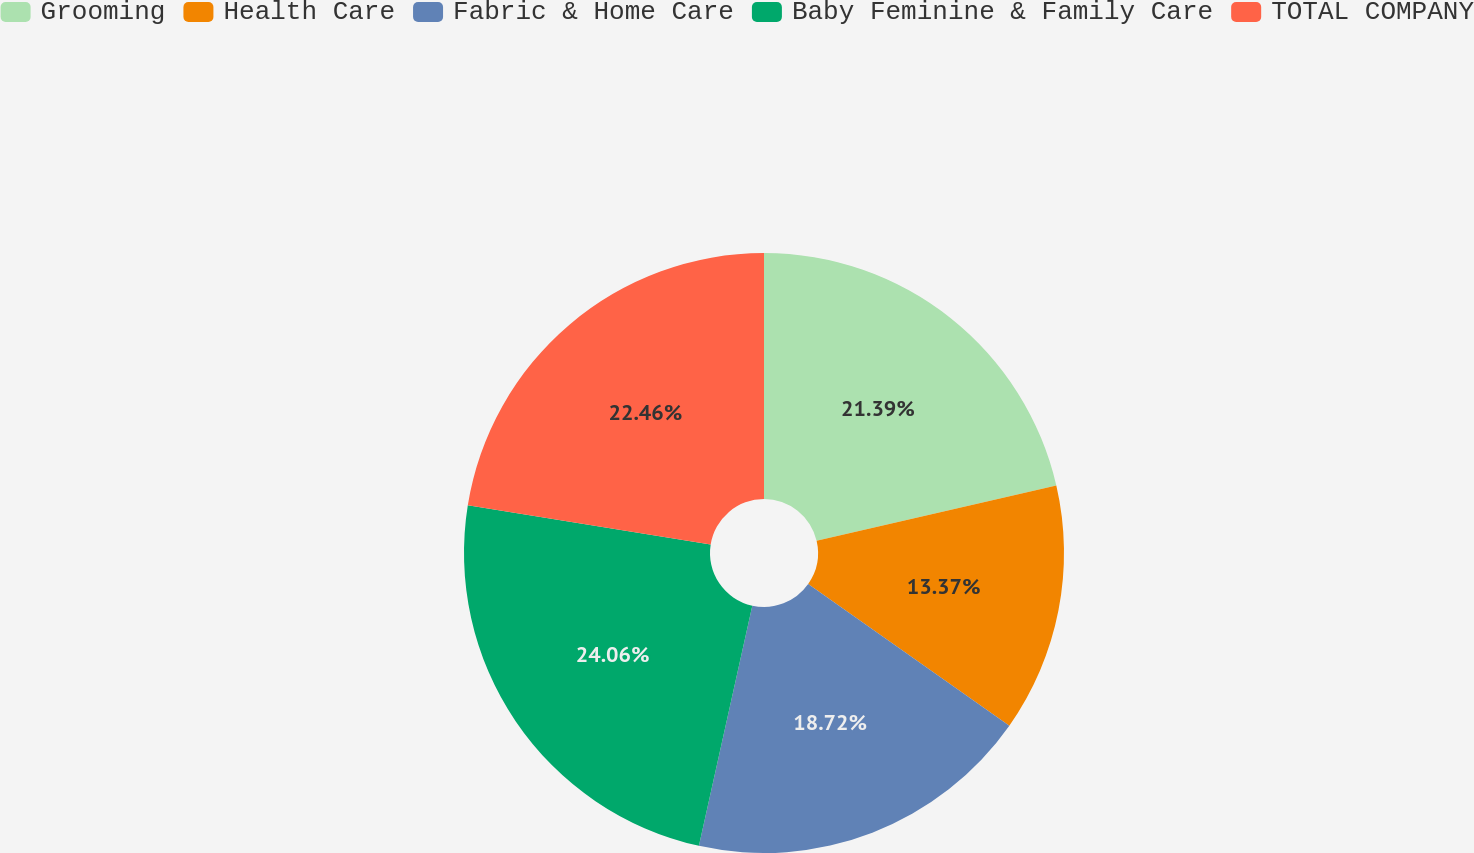Convert chart. <chart><loc_0><loc_0><loc_500><loc_500><pie_chart><fcel>Grooming<fcel>Health Care<fcel>Fabric & Home Care<fcel>Baby Feminine & Family Care<fcel>TOTAL COMPANY<nl><fcel>21.39%<fcel>13.37%<fcel>18.72%<fcel>24.06%<fcel>22.46%<nl></chart> 